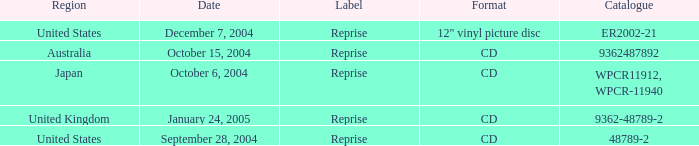What was the content of the catalog on october 15, 2004? 9362487892.0. 